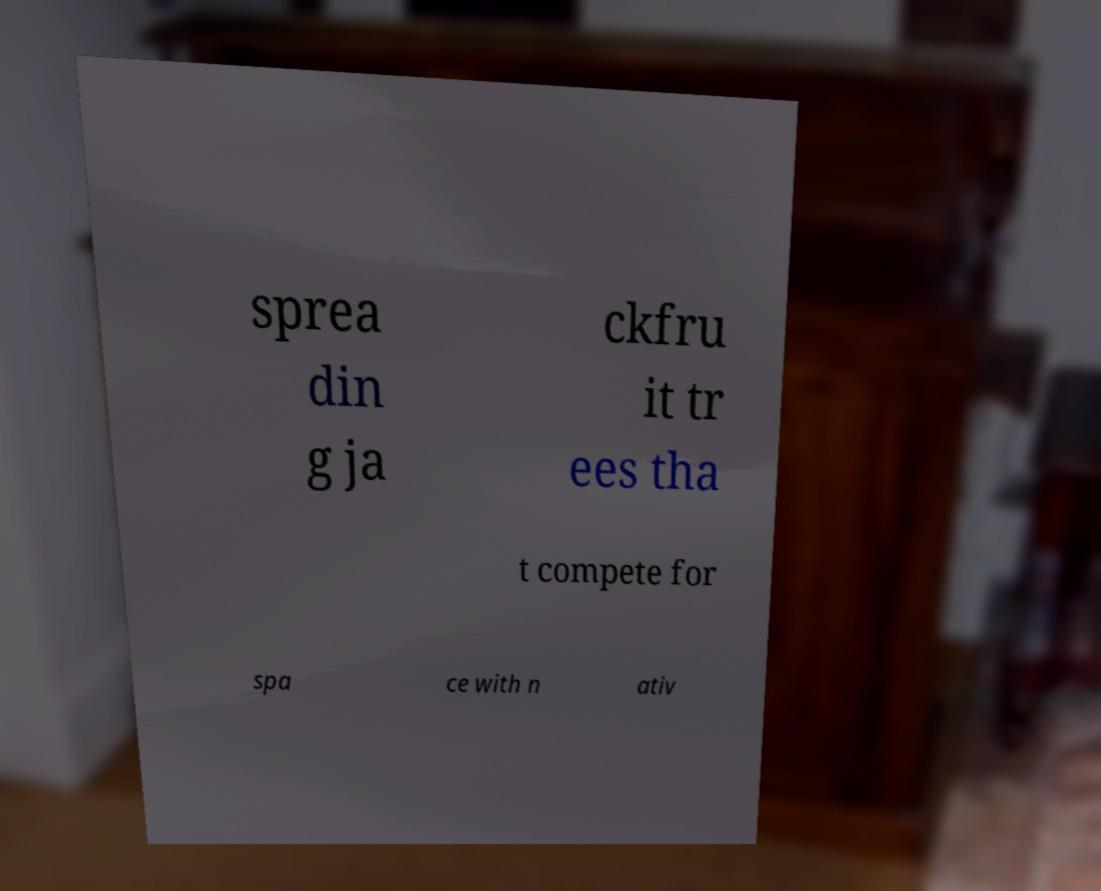There's text embedded in this image that I need extracted. Can you transcribe it verbatim? sprea din g ja ckfru it tr ees tha t compete for spa ce with n ativ 